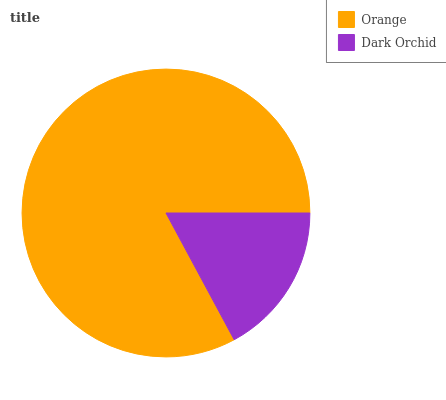Is Dark Orchid the minimum?
Answer yes or no. Yes. Is Orange the maximum?
Answer yes or no. Yes. Is Dark Orchid the maximum?
Answer yes or no. No. Is Orange greater than Dark Orchid?
Answer yes or no. Yes. Is Dark Orchid less than Orange?
Answer yes or no. Yes. Is Dark Orchid greater than Orange?
Answer yes or no. No. Is Orange less than Dark Orchid?
Answer yes or no. No. Is Orange the high median?
Answer yes or no. Yes. Is Dark Orchid the low median?
Answer yes or no. Yes. Is Dark Orchid the high median?
Answer yes or no. No. Is Orange the low median?
Answer yes or no. No. 